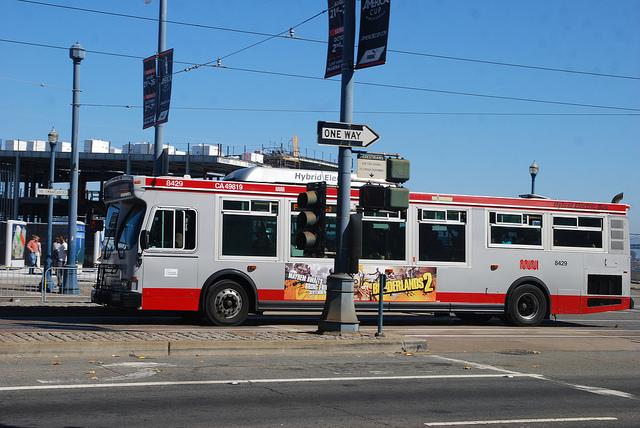What type of company paid to have their product advertised on the bus?

Choices:
A) travel
B) movie
C) video game
D) food video game 